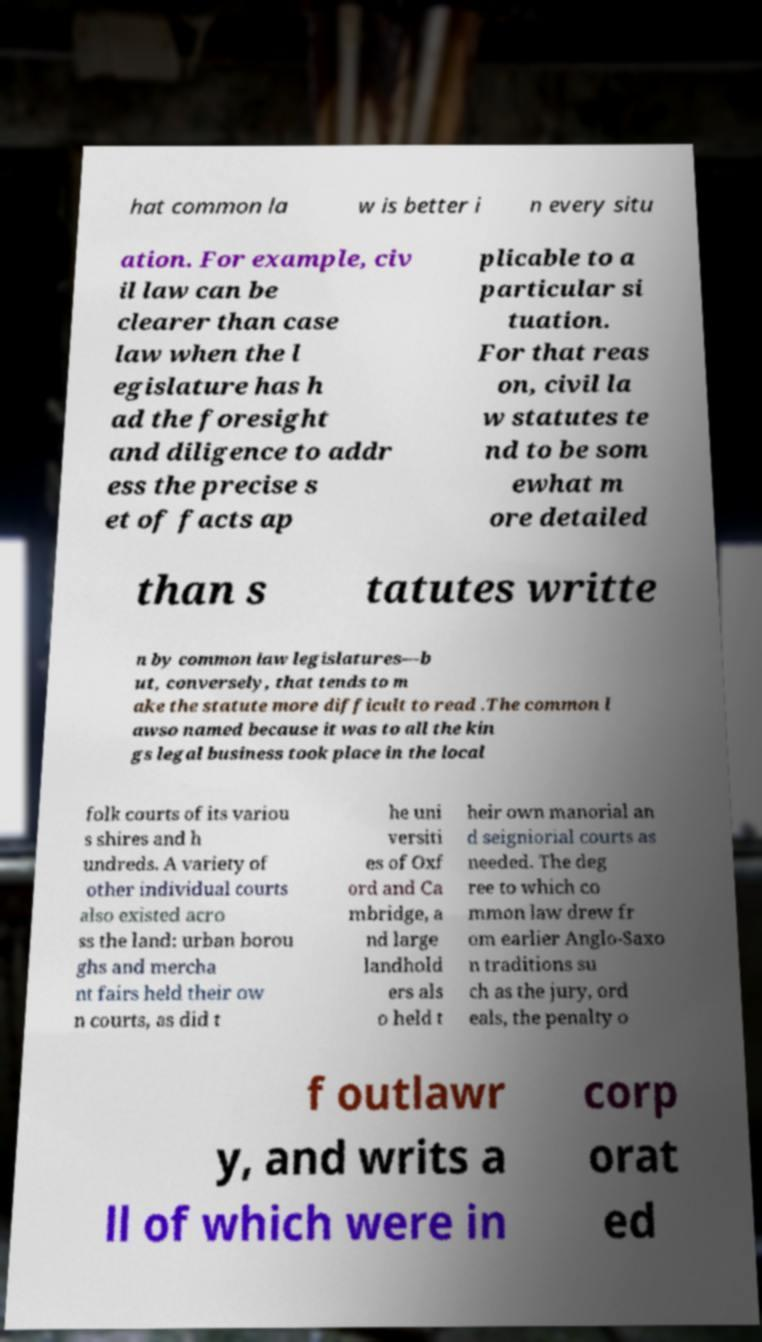Could you extract and type out the text from this image? hat common la w is better i n every situ ation. For example, civ il law can be clearer than case law when the l egislature has h ad the foresight and diligence to addr ess the precise s et of facts ap plicable to a particular si tuation. For that reas on, civil la w statutes te nd to be som ewhat m ore detailed than s tatutes writte n by common law legislatures—b ut, conversely, that tends to m ake the statute more difficult to read .The common l awso named because it was to all the kin gs legal business took place in the local folk courts of its variou s shires and h undreds. A variety of other individual courts also existed acro ss the land: urban borou ghs and mercha nt fairs held their ow n courts, as did t he uni versiti es of Oxf ord and Ca mbridge, a nd large landhold ers als o held t heir own manorial an d seigniorial courts as needed. The deg ree to which co mmon law drew fr om earlier Anglo-Saxo n traditions su ch as the jury, ord eals, the penalty o f outlawr y, and writs a ll of which were in corp orat ed 